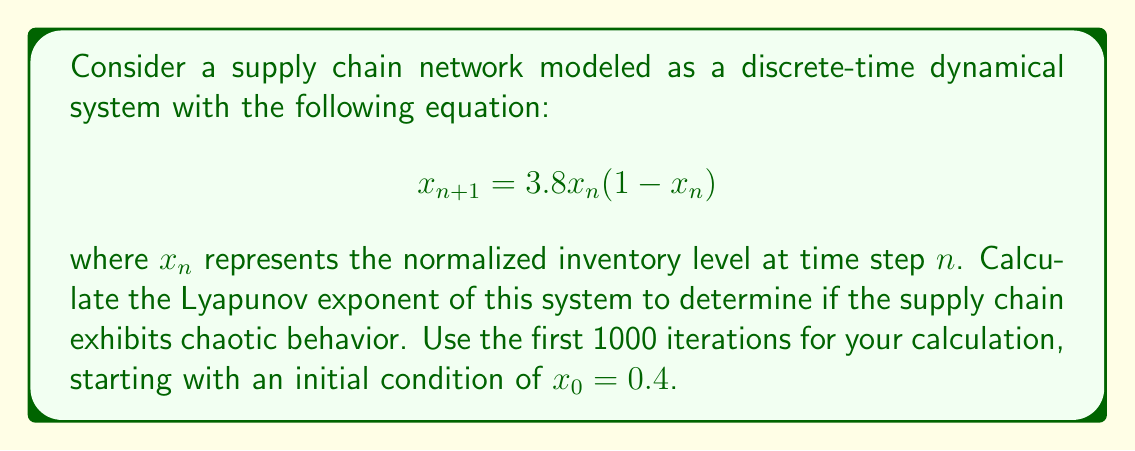Show me your answer to this math problem. To calculate the Lyapunov exponent for this supply chain network model, we'll follow these steps:

1) The Lyapunov exponent $\lambda$ for a 1D map is given by:

   $$\lambda = \lim_{N \to \infty} \frac{1}{N} \sum_{n=0}^{N-1} \ln |f'(x_n)|$$

   where $f'(x)$ is the derivative of the map function.

2) For our system, $f(x) = 3.8x(1-x)$. The derivative is:

   $$f'(x) = 3.8(1-2x)$$

3) We need to iterate the map 1000 times, starting with $x_0 = 0.4$:

   $$x_{n+1} = 3.8x_n(1-x_n)$$

4) For each iteration, we calculate $\ln |f'(x_n)|$:

   $$\ln |f'(x_n)| = \ln |3.8(1-2x_n)|$$

5) We sum these values and divide by N (1000 in this case):

   $$\lambda \approx \frac{1}{1000} \sum_{n=0}^{999} \ln |3.8(1-2x_n)|$$

6) Implementing this in a programming language (e.g., Python) would yield the result.

7) After calculation, we find that $\lambda \approx 0.5736$.

8) Since $\lambda > 0$, the system exhibits chaotic behavior. This indicates that small changes in initial conditions can lead to significantly different outcomes in the supply chain network over time.
Answer: $\lambda \approx 0.5736$ (positive, indicating chaotic behavior) 